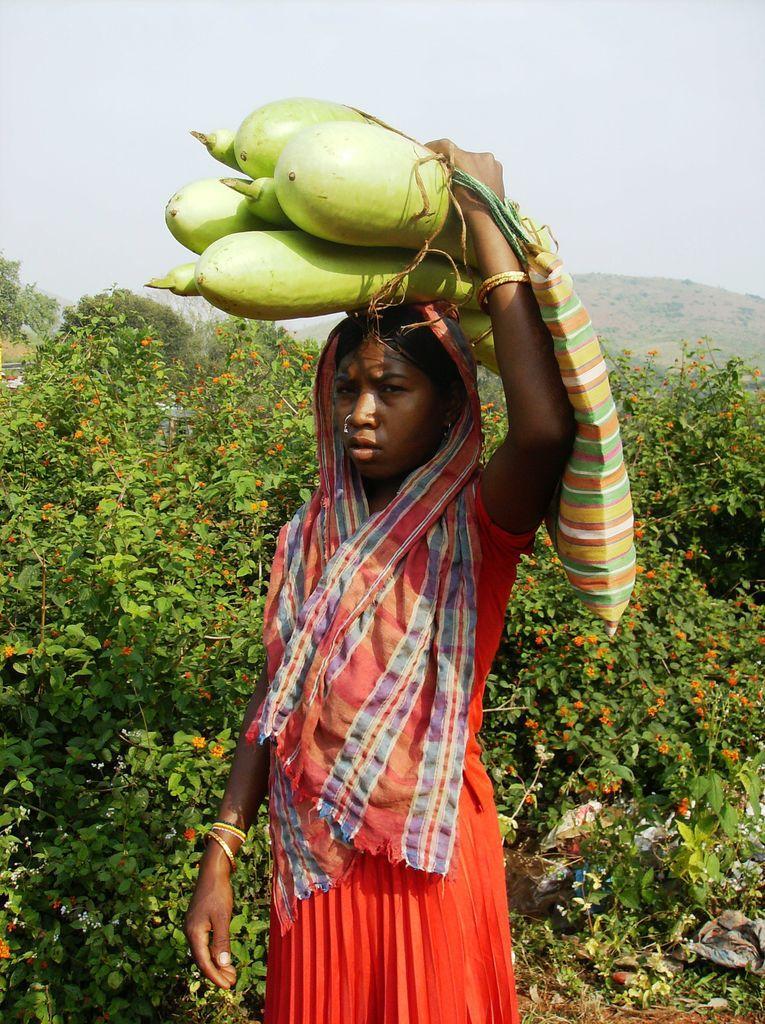Please provide a concise description of this image. In this picture there is a Indian girl wearing orange color dress, standing in the front and holding some bottle guard on the head. Behind there are some plants. 